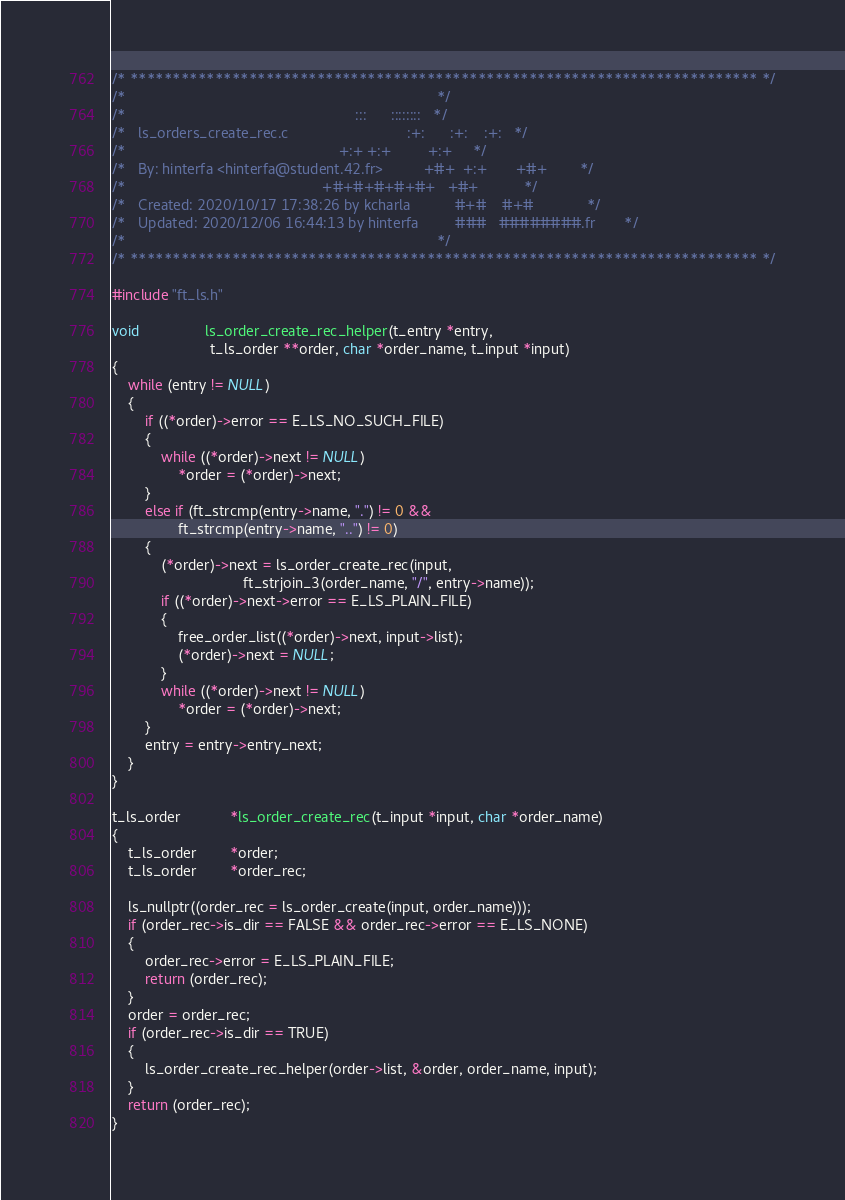<code> <loc_0><loc_0><loc_500><loc_500><_C_>/* ************************************************************************** */
/*                                                                            */
/*                                                        :::      ::::::::   */
/*   ls_orders_create_rec.c                             :+:      :+:    :+:   */
/*                                                    +:+ +:+         +:+     */
/*   By: hinterfa <hinterfa@student.42.fr>          +#+  +:+       +#+        */
/*                                                +#+#+#+#+#+   +#+           */
/*   Created: 2020/10/17 17:38:26 by kcharla           #+#    #+#             */
/*   Updated: 2020/12/06 16:44:13 by hinterfa         ###   ########.fr       */
/*                                                                            */
/* ************************************************************************** */

#include "ft_ls.h"

void				ls_order_create_rec_helper(t_entry *entry,
						t_ls_order **order, char *order_name, t_input *input)
{
	while (entry != NULL)
	{
		if ((*order)->error == E_LS_NO_SUCH_FILE)
		{
			while ((*order)->next != NULL)
				*order = (*order)->next;
		}
		else if (ft_strcmp(entry->name, ".") != 0 &&
				ft_strcmp(entry->name, "..") != 0)
		{
			(*order)->next = ls_order_create_rec(input,
								ft_strjoin_3(order_name, "/", entry->name));
			if ((*order)->next->error == E_LS_PLAIN_FILE)
			{
				free_order_list((*order)->next, input->list);
				(*order)->next = NULL;
			}
			while ((*order)->next != NULL)
				*order = (*order)->next;
		}
		entry = entry->entry_next;
	}
}

t_ls_order			*ls_order_create_rec(t_input *input, char *order_name)
{
	t_ls_order		*order;
	t_ls_order		*order_rec;

	ls_nullptr((order_rec = ls_order_create(input, order_name)));
	if (order_rec->is_dir == FALSE && order_rec->error == E_LS_NONE)
	{
		order_rec->error = E_LS_PLAIN_FILE;
		return (order_rec);
	}
	order = order_rec;
	if (order_rec->is_dir == TRUE)
	{
		ls_order_create_rec_helper(order->list, &order, order_name, input);
	}
	return (order_rec);
}
</code> 